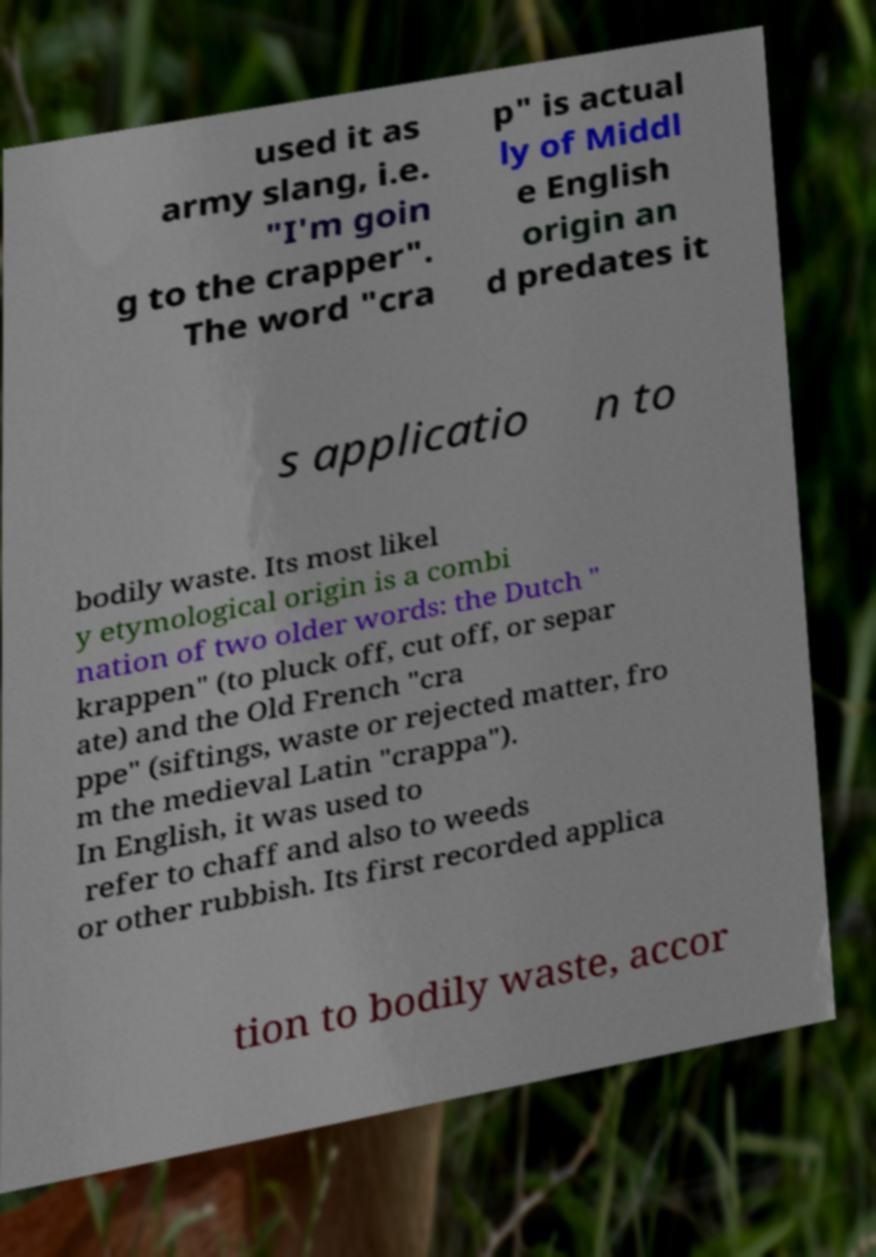Please read and relay the text visible in this image. What does it say? used it as army slang, i.e. "I'm goin g to the crapper". The word "cra p" is actual ly of Middl e English origin an d predates it s applicatio n to bodily waste. Its most likel y etymological origin is a combi nation of two older words: the Dutch " krappen" (to pluck off, cut off, or separ ate) and the Old French "cra ppe" (siftings, waste or rejected matter, fro m the medieval Latin "crappa"). In English, it was used to refer to chaff and also to weeds or other rubbish. Its first recorded applica tion to bodily waste, accor 